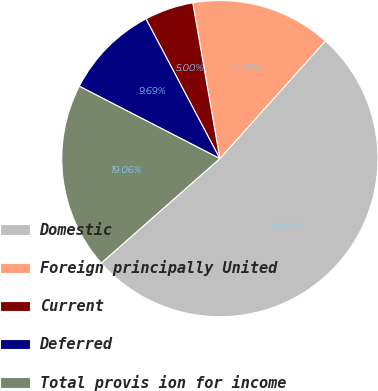Convert chart. <chart><loc_0><loc_0><loc_500><loc_500><pie_chart><fcel>Domestic<fcel>Foreign principally United<fcel>Current<fcel>Deferred<fcel>Total provis ion for income<nl><fcel>51.87%<fcel>14.38%<fcel>5.0%<fcel>9.69%<fcel>19.06%<nl></chart> 